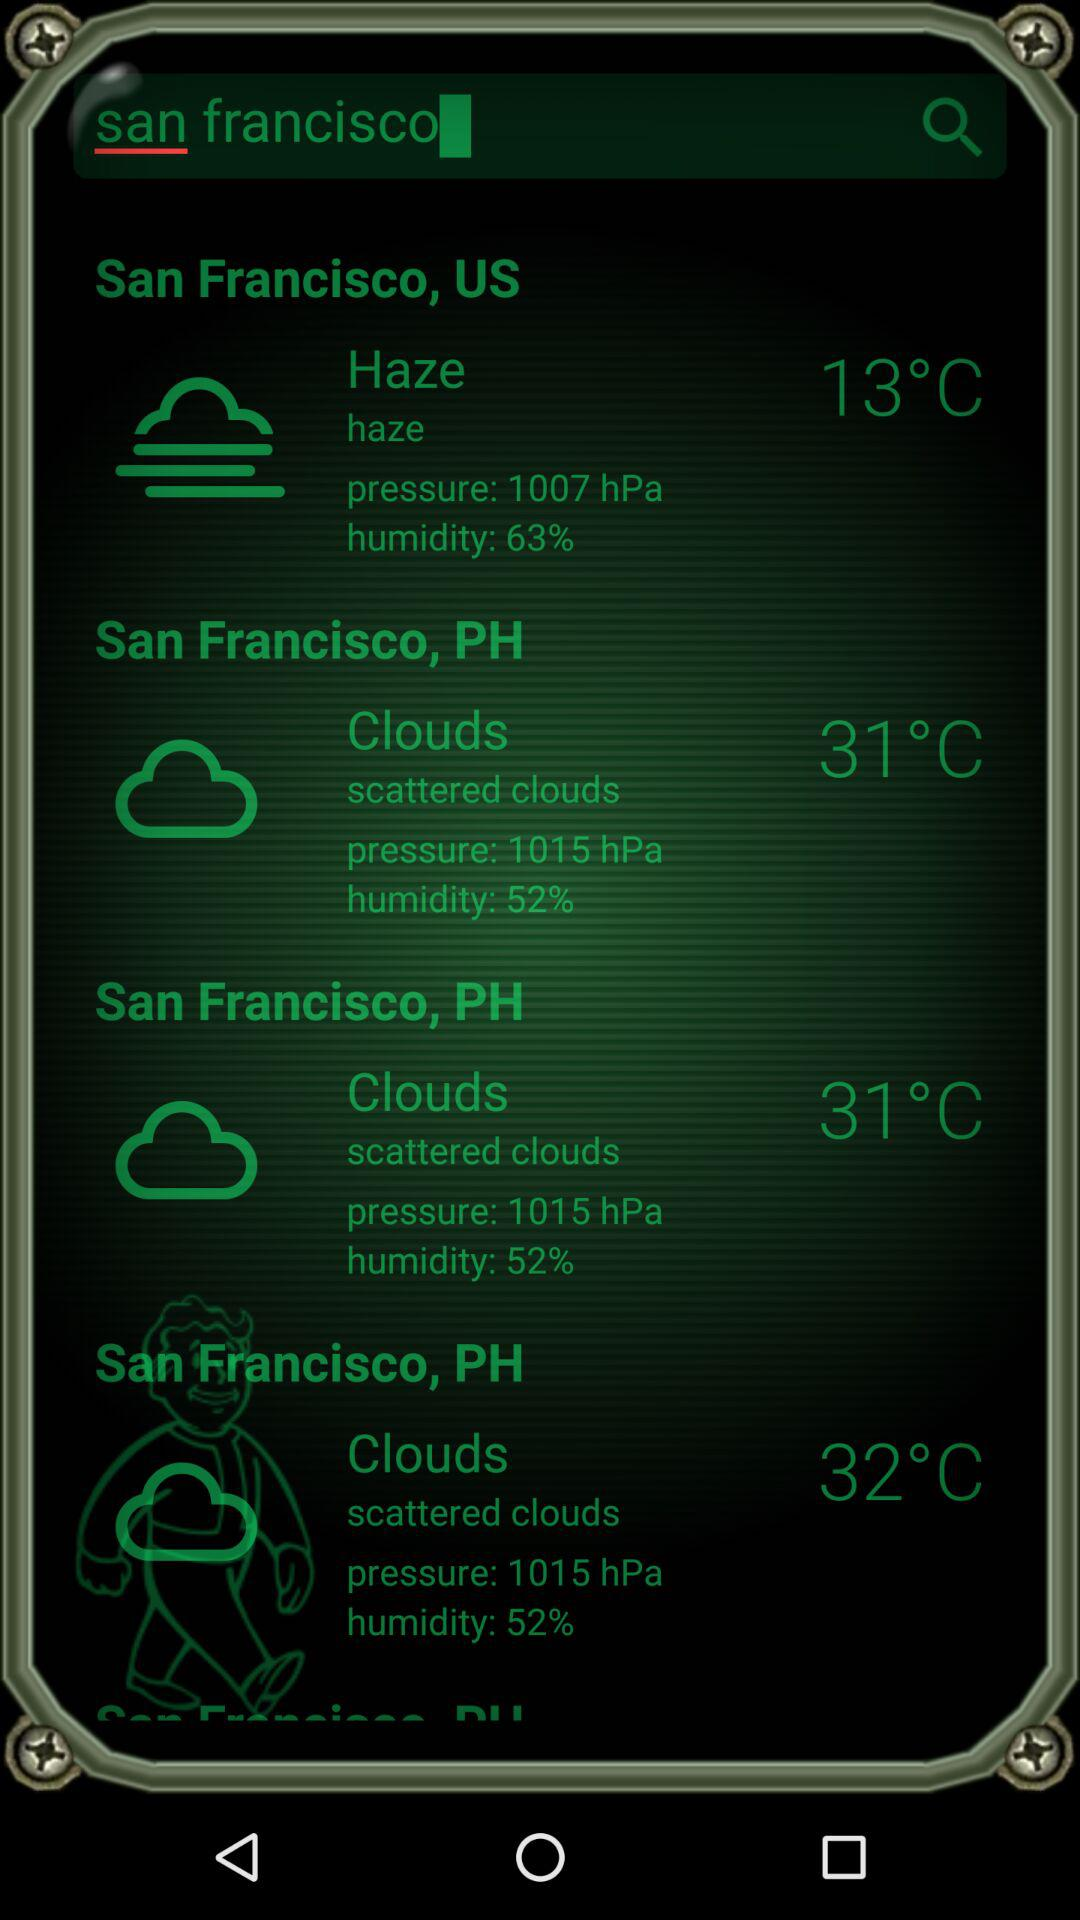Which setting is set at 52% in the cloud option?
When the provided information is insufficient, respond with <no answer>. <no answer> 